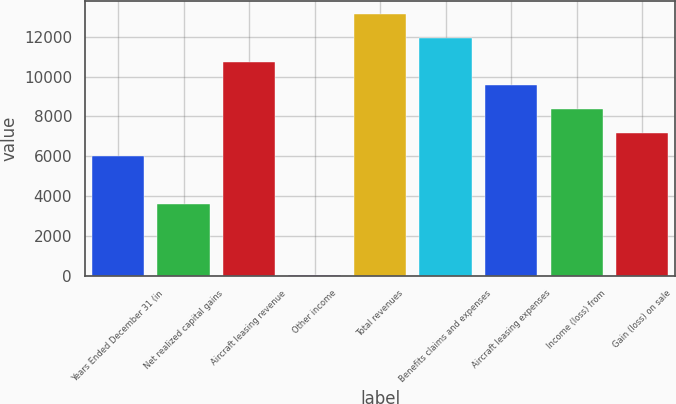Convert chart. <chart><loc_0><loc_0><loc_500><loc_500><bar_chart><fcel>Years Ended December 31 (in<fcel>Net realized capital gains<fcel>Aircraft leasing revenue<fcel>Other income<fcel>Total revenues<fcel>Benefits claims and expenses<fcel>Aircraft leasing expenses<fcel>Income (loss) from<fcel>Gain (loss) on sale<nl><fcel>5993<fcel>3615<fcel>10749<fcel>48<fcel>13127<fcel>11938<fcel>9560<fcel>8371<fcel>7182<nl></chart> 